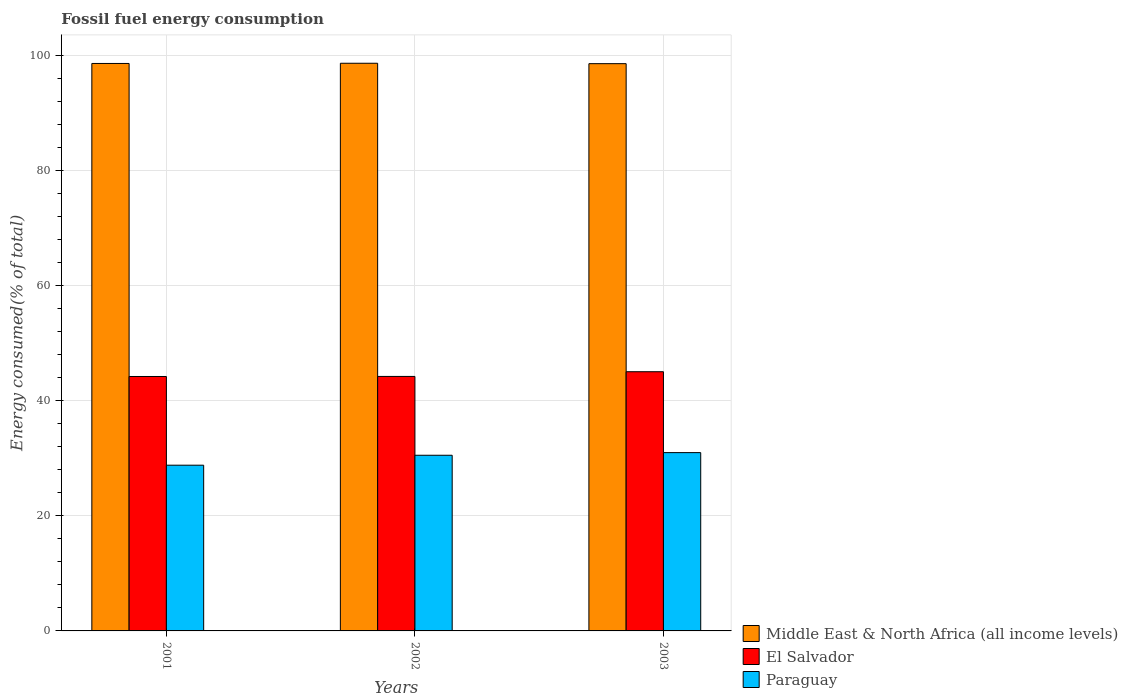How many different coloured bars are there?
Your response must be concise. 3. How many groups of bars are there?
Your answer should be very brief. 3. How many bars are there on the 3rd tick from the left?
Keep it short and to the point. 3. How many bars are there on the 3rd tick from the right?
Your answer should be very brief. 3. What is the label of the 1st group of bars from the left?
Provide a short and direct response. 2001. What is the percentage of energy consumed in Paraguay in 2002?
Your answer should be compact. 30.51. Across all years, what is the maximum percentage of energy consumed in Paraguay?
Provide a succinct answer. 30.97. Across all years, what is the minimum percentage of energy consumed in Middle East & North Africa (all income levels)?
Offer a very short reply. 98.54. In which year was the percentage of energy consumed in El Salvador maximum?
Give a very brief answer. 2003. In which year was the percentage of energy consumed in El Salvador minimum?
Offer a very short reply. 2001. What is the total percentage of energy consumed in El Salvador in the graph?
Give a very brief answer. 133.43. What is the difference between the percentage of energy consumed in El Salvador in 2002 and that in 2003?
Make the answer very short. -0.82. What is the difference between the percentage of energy consumed in Middle East & North Africa (all income levels) in 2003 and the percentage of energy consumed in El Salvador in 2001?
Give a very brief answer. 54.34. What is the average percentage of energy consumed in Paraguay per year?
Provide a succinct answer. 30.09. In the year 2002, what is the difference between the percentage of energy consumed in Paraguay and percentage of energy consumed in El Salvador?
Your response must be concise. -13.7. In how many years, is the percentage of energy consumed in Paraguay greater than 48 %?
Ensure brevity in your answer.  0. What is the ratio of the percentage of energy consumed in Middle East & North Africa (all income levels) in 2001 to that in 2002?
Provide a short and direct response. 1. What is the difference between the highest and the second highest percentage of energy consumed in Paraguay?
Offer a terse response. 0.46. What is the difference between the highest and the lowest percentage of energy consumed in El Salvador?
Give a very brief answer. 0.83. What does the 1st bar from the left in 2003 represents?
Ensure brevity in your answer.  Middle East & North Africa (all income levels). What does the 1st bar from the right in 2003 represents?
Keep it short and to the point. Paraguay. How many bars are there?
Keep it short and to the point. 9. Are all the bars in the graph horizontal?
Keep it short and to the point. No. What is the difference between two consecutive major ticks on the Y-axis?
Your answer should be compact. 20. Does the graph contain grids?
Make the answer very short. Yes. Where does the legend appear in the graph?
Your answer should be compact. Bottom right. How are the legend labels stacked?
Keep it short and to the point. Vertical. What is the title of the graph?
Your response must be concise. Fossil fuel energy consumption. What is the label or title of the X-axis?
Offer a terse response. Years. What is the label or title of the Y-axis?
Ensure brevity in your answer.  Energy consumed(% of total). What is the Energy consumed(% of total) in Middle East & North Africa (all income levels) in 2001?
Provide a short and direct response. 98.57. What is the Energy consumed(% of total) of El Salvador in 2001?
Provide a succinct answer. 44.2. What is the Energy consumed(% of total) of Paraguay in 2001?
Your answer should be compact. 28.79. What is the Energy consumed(% of total) of Middle East & North Africa (all income levels) in 2002?
Your response must be concise. 98.61. What is the Energy consumed(% of total) in El Salvador in 2002?
Keep it short and to the point. 44.21. What is the Energy consumed(% of total) of Paraguay in 2002?
Your answer should be compact. 30.51. What is the Energy consumed(% of total) of Middle East & North Africa (all income levels) in 2003?
Provide a short and direct response. 98.54. What is the Energy consumed(% of total) in El Salvador in 2003?
Your response must be concise. 45.02. What is the Energy consumed(% of total) of Paraguay in 2003?
Your answer should be very brief. 30.97. Across all years, what is the maximum Energy consumed(% of total) of Middle East & North Africa (all income levels)?
Your answer should be compact. 98.61. Across all years, what is the maximum Energy consumed(% of total) in El Salvador?
Give a very brief answer. 45.02. Across all years, what is the maximum Energy consumed(% of total) of Paraguay?
Offer a terse response. 30.97. Across all years, what is the minimum Energy consumed(% of total) in Middle East & North Africa (all income levels)?
Your answer should be compact. 98.54. Across all years, what is the minimum Energy consumed(% of total) of El Salvador?
Provide a short and direct response. 44.2. Across all years, what is the minimum Energy consumed(% of total) in Paraguay?
Your answer should be compact. 28.79. What is the total Energy consumed(% of total) in Middle East & North Africa (all income levels) in the graph?
Make the answer very short. 295.72. What is the total Energy consumed(% of total) in El Salvador in the graph?
Your response must be concise. 133.43. What is the total Energy consumed(% of total) of Paraguay in the graph?
Ensure brevity in your answer.  90.27. What is the difference between the Energy consumed(% of total) of Middle East & North Africa (all income levels) in 2001 and that in 2002?
Offer a very short reply. -0.03. What is the difference between the Energy consumed(% of total) of El Salvador in 2001 and that in 2002?
Make the answer very short. -0.01. What is the difference between the Energy consumed(% of total) of Paraguay in 2001 and that in 2002?
Your answer should be compact. -1.73. What is the difference between the Energy consumed(% of total) of Middle East & North Africa (all income levels) in 2001 and that in 2003?
Make the answer very short. 0.04. What is the difference between the Energy consumed(% of total) of El Salvador in 2001 and that in 2003?
Your response must be concise. -0.83. What is the difference between the Energy consumed(% of total) of Paraguay in 2001 and that in 2003?
Your answer should be compact. -2.19. What is the difference between the Energy consumed(% of total) of Middle East & North Africa (all income levels) in 2002 and that in 2003?
Ensure brevity in your answer.  0.07. What is the difference between the Energy consumed(% of total) of El Salvador in 2002 and that in 2003?
Make the answer very short. -0.82. What is the difference between the Energy consumed(% of total) of Paraguay in 2002 and that in 2003?
Provide a short and direct response. -0.46. What is the difference between the Energy consumed(% of total) in Middle East & North Africa (all income levels) in 2001 and the Energy consumed(% of total) in El Salvador in 2002?
Ensure brevity in your answer.  54.37. What is the difference between the Energy consumed(% of total) in Middle East & North Africa (all income levels) in 2001 and the Energy consumed(% of total) in Paraguay in 2002?
Give a very brief answer. 68.06. What is the difference between the Energy consumed(% of total) in El Salvador in 2001 and the Energy consumed(% of total) in Paraguay in 2002?
Your answer should be very brief. 13.68. What is the difference between the Energy consumed(% of total) of Middle East & North Africa (all income levels) in 2001 and the Energy consumed(% of total) of El Salvador in 2003?
Your response must be concise. 53.55. What is the difference between the Energy consumed(% of total) in Middle East & North Africa (all income levels) in 2001 and the Energy consumed(% of total) in Paraguay in 2003?
Ensure brevity in your answer.  67.6. What is the difference between the Energy consumed(% of total) in El Salvador in 2001 and the Energy consumed(% of total) in Paraguay in 2003?
Offer a terse response. 13.22. What is the difference between the Energy consumed(% of total) in Middle East & North Africa (all income levels) in 2002 and the Energy consumed(% of total) in El Salvador in 2003?
Give a very brief answer. 53.58. What is the difference between the Energy consumed(% of total) in Middle East & North Africa (all income levels) in 2002 and the Energy consumed(% of total) in Paraguay in 2003?
Your answer should be very brief. 67.64. What is the difference between the Energy consumed(% of total) in El Salvador in 2002 and the Energy consumed(% of total) in Paraguay in 2003?
Offer a very short reply. 13.24. What is the average Energy consumed(% of total) in Middle East & North Africa (all income levels) per year?
Your response must be concise. 98.57. What is the average Energy consumed(% of total) in El Salvador per year?
Your response must be concise. 44.48. What is the average Energy consumed(% of total) in Paraguay per year?
Provide a succinct answer. 30.09. In the year 2001, what is the difference between the Energy consumed(% of total) of Middle East & North Africa (all income levels) and Energy consumed(% of total) of El Salvador?
Your answer should be very brief. 54.38. In the year 2001, what is the difference between the Energy consumed(% of total) in Middle East & North Africa (all income levels) and Energy consumed(% of total) in Paraguay?
Provide a succinct answer. 69.79. In the year 2001, what is the difference between the Energy consumed(% of total) in El Salvador and Energy consumed(% of total) in Paraguay?
Make the answer very short. 15.41. In the year 2002, what is the difference between the Energy consumed(% of total) of Middle East & North Africa (all income levels) and Energy consumed(% of total) of El Salvador?
Offer a very short reply. 54.4. In the year 2002, what is the difference between the Energy consumed(% of total) of Middle East & North Africa (all income levels) and Energy consumed(% of total) of Paraguay?
Make the answer very short. 68.1. In the year 2002, what is the difference between the Energy consumed(% of total) of El Salvador and Energy consumed(% of total) of Paraguay?
Keep it short and to the point. 13.7. In the year 2003, what is the difference between the Energy consumed(% of total) in Middle East & North Africa (all income levels) and Energy consumed(% of total) in El Salvador?
Give a very brief answer. 53.51. In the year 2003, what is the difference between the Energy consumed(% of total) in Middle East & North Africa (all income levels) and Energy consumed(% of total) in Paraguay?
Offer a terse response. 67.57. In the year 2003, what is the difference between the Energy consumed(% of total) in El Salvador and Energy consumed(% of total) in Paraguay?
Provide a succinct answer. 14.05. What is the ratio of the Energy consumed(% of total) of El Salvador in 2001 to that in 2002?
Offer a very short reply. 1. What is the ratio of the Energy consumed(% of total) of Paraguay in 2001 to that in 2002?
Your answer should be compact. 0.94. What is the ratio of the Energy consumed(% of total) of Middle East & North Africa (all income levels) in 2001 to that in 2003?
Make the answer very short. 1. What is the ratio of the Energy consumed(% of total) in El Salvador in 2001 to that in 2003?
Your answer should be compact. 0.98. What is the ratio of the Energy consumed(% of total) of Paraguay in 2001 to that in 2003?
Your response must be concise. 0.93. What is the ratio of the Energy consumed(% of total) of Middle East & North Africa (all income levels) in 2002 to that in 2003?
Your response must be concise. 1. What is the ratio of the Energy consumed(% of total) of El Salvador in 2002 to that in 2003?
Provide a short and direct response. 0.98. What is the ratio of the Energy consumed(% of total) in Paraguay in 2002 to that in 2003?
Provide a succinct answer. 0.99. What is the difference between the highest and the second highest Energy consumed(% of total) in Middle East & North Africa (all income levels)?
Offer a terse response. 0.03. What is the difference between the highest and the second highest Energy consumed(% of total) of El Salvador?
Your answer should be very brief. 0.82. What is the difference between the highest and the second highest Energy consumed(% of total) of Paraguay?
Make the answer very short. 0.46. What is the difference between the highest and the lowest Energy consumed(% of total) of Middle East & North Africa (all income levels)?
Keep it short and to the point. 0.07. What is the difference between the highest and the lowest Energy consumed(% of total) of El Salvador?
Offer a very short reply. 0.83. What is the difference between the highest and the lowest Energy consumed(% of total) of Paraguay?
Give a very brief answer. 2.19. 